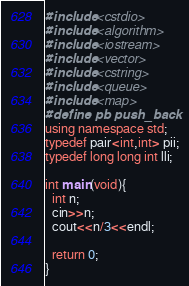Convert code to text. <code><loc_0><loc_0><loc_500><loc_500><_C++_>#include <cstdio>
#include <algorithm>
#include <iostream>
#include <vector>
#include <cstring>
#include <queue>
#include <map>
#define pb push_back
using namespace std;
typedef pair<int,int> pii;
typedef long long int lli;

int main(void){
  int n;
  cin>>n;
  cout<<n/3<<endl;
  
  return 0;
}
</code> 